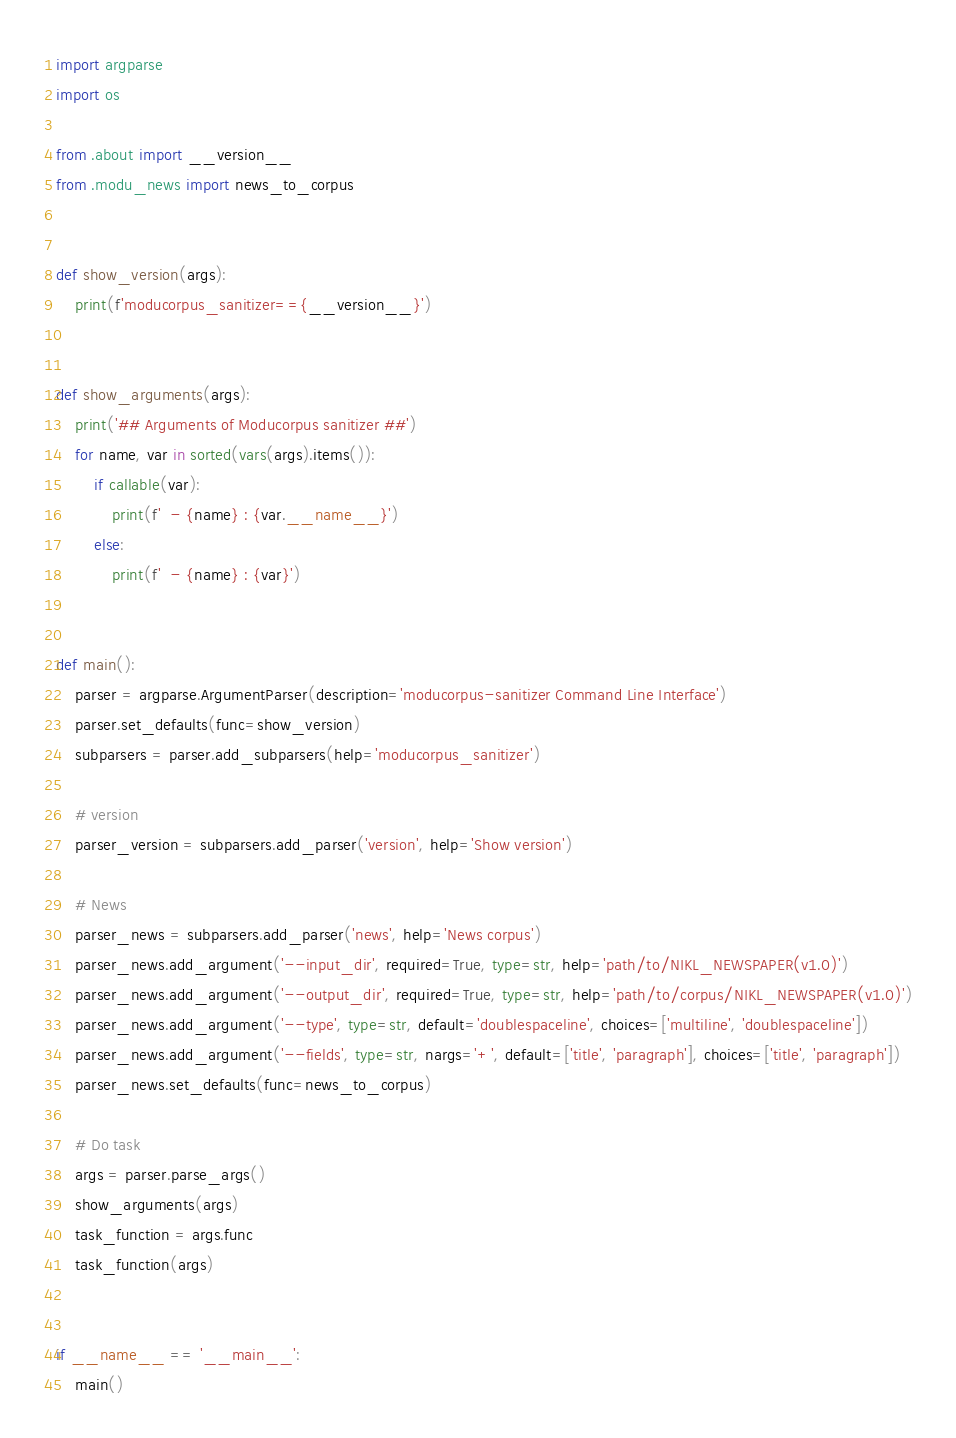Convert code to text. <code><loc_0><loc_0><loc_500><loc_500><_Python_>import argparse
import os

from .about import __version__
from .modu_news import news_to_corpus


def show_version(args):
    print(f'moducorpus_sanitizer=={__version__}')


def show_arguments(args):
    print('## Arguments of Moducorpus sanitizer ##')
    for name, var in sorted(vars(args).items()):
        if callable(var):
            print(f'  - {name} : {var.__name__}')
        else:
            print(f'  - {name} : {var}')


def main():
    parser = argparse.ArgumentParser(description='moducorpus-sanitizer Command Line Interface')
    parser.set_defaults(func=show_version)
    subparsers = parser.add_subparsers(help='moducorpus_sanitizer')

    # version
    parser_version = subparsers.add_parser('version', help='Show version')

    # News
    parser_news = subparsers.add_parser('news', help='News corpus')
    parser_news.add_argument('--input_dir', required=True, type=str, help='path/to/NIKL_NEWSPAPER(v1.0)')
    parser_news.add_argument('--output_dir', required=True, type=str, help='path/to/corpus/NIKL_NEWSPAPER(v1.0)')
    parser_news.add_argument('--type', type=str, default='doublespaceline', choices=['multiline', 'doublespaceline'])
    parser_news.add_argument('--fields', type=str, nargs='+', default=['title', 'paragraph'], choices=['title', 'paragraph'])
    parser_news.set_defaults(func=news_to_corpus)

    # Do task
    args = parser.parse_args()
    show_arguments(args)
    task_function = args.func
    task_function(args)


if __name__ == '__main__':
    main()</code> 